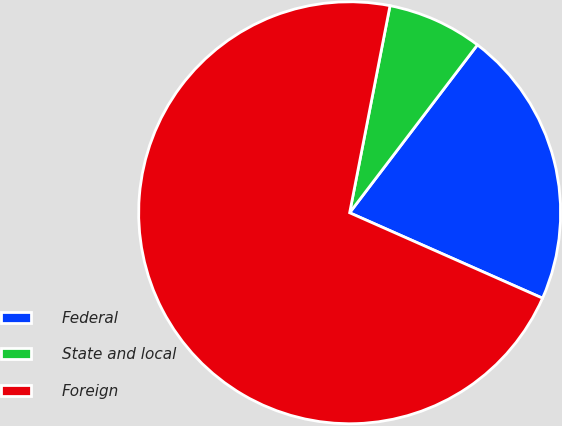<chart> <loc_0><loc_0><loc_500><loc_500><pie_chart><fcel>Federal<fcel>State and local<fcel>Foreign<nl><fcel>21.28%<fcel>7.29%<fcel>71.43%<nl></chart> 